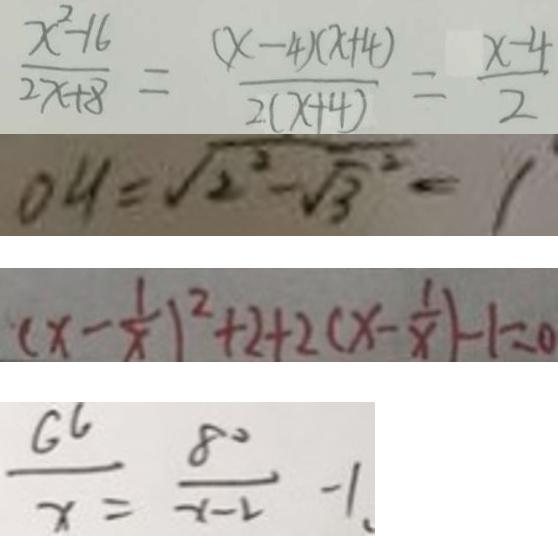<formula> <loc_0><loc_0><loc_500><loc_500>\frac { x ^ { 2 } - 1 6 } { 2 x + 8 } = \frac { ( x - 4 ) \times ( - 4 ) } { 2 ( x + 4 ) } = \frac { x - 4 } { 2 } 
 O H = \sqrt { 2 ^ { 2 } - \sqrt { 3 } ^ { 2 } } = 1 
 ( x - \frac { 1 } { x } ) ^ { 2 } + 2 + 2 ( x - \frac { 1 } { x } ) - 1 = 0 
 \frac { G 6 } { x } = \frac { 8 0 } { x - 2 } - 1 .</formula> 